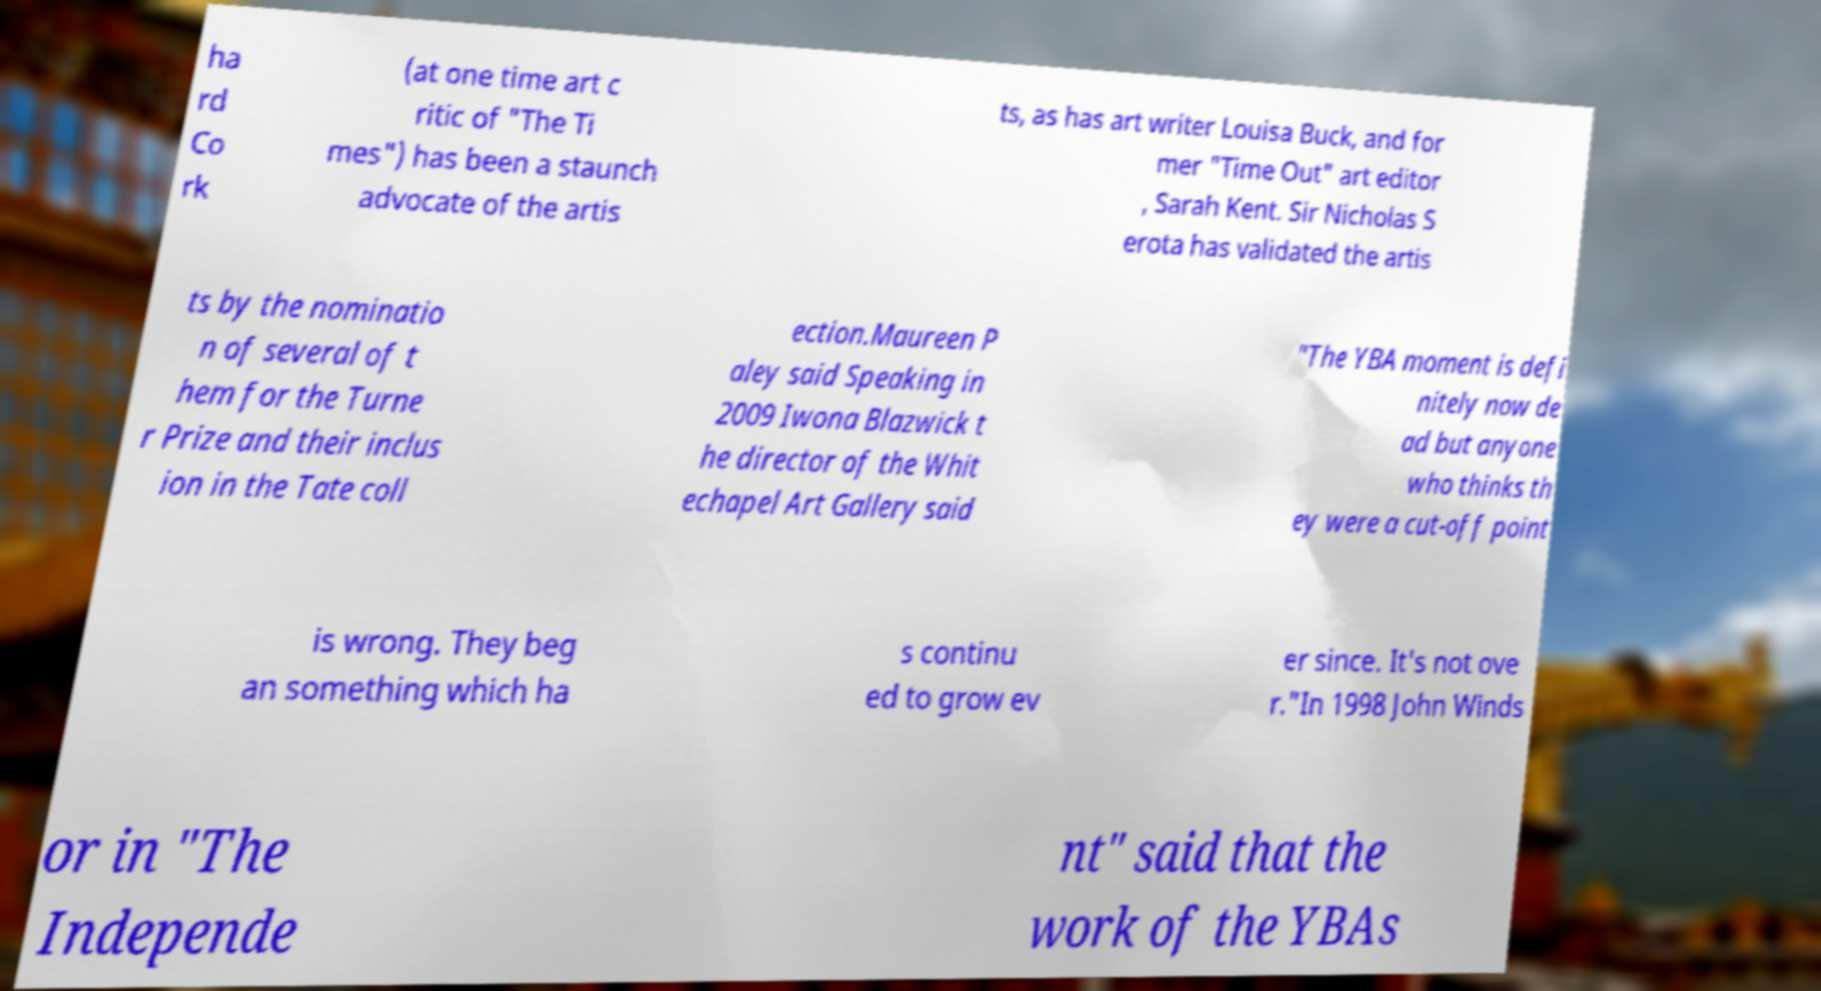Could you extract and type out the text from this image? ha rd Co rk (at one time art c ritic of "The Ti mes") has been a staunch advocate of the artis ts, as has art writer Louisa Buck, and for mer "Time Out" art editor , Sarah Kent. Sir Nicholas S erota has validated the artis ts by the nominatio n of several of t hem for the Turne r Prize and their inclus ion in the Tate coll ection.Maureen P aley said Speaking in 2009 Iwona Blazwick t he director of the Whit echapel Art Gallery said "The YBA moment is defi nitely now de ad but anyone who thinks th ey were a cut-off point is wrong. They beg an something which ha s continu ed to grow ev er since. It's not ove r."In 1998 John Winds or in "The Independe nt" said that the work of the YBAs 